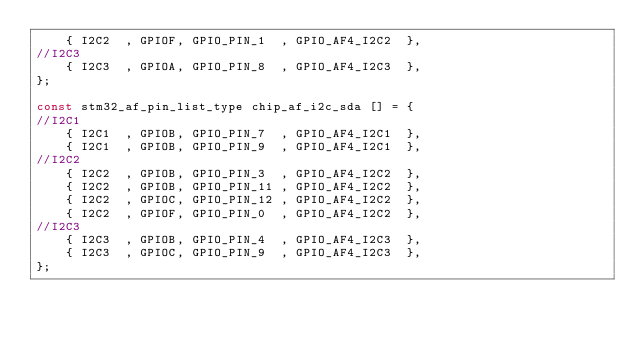<code> <loc_0><loc_0><loc_500><loc_500><_C_>    { I2C2  , GPIOF, GPIO_PIN_1  , GPIO_AF4_I2C2  }, 
//I2C3
    { I2C3  , GPIOA, GPIO_PIN_8  , GPIO_AF4_I2C3  }, 
}; 

const stm32_af_pin_list_type chip_af_i2c_sda [] = {
//I2C1
    { I2C1  , GPIOB, GPIO_PIN_7  , GPIO_AF4_I2C1  }, 
    { I2C1  , GPIOB, GPIO_PIN_9  , GPIO_AF4_I2C1  }, 
//I2C2
    { I2C2  , GPIOB, GPIO_PIN_3  , GPIO_AF4_I2C2  }, 
    { I2C2  , GPIOB, GPIO_PIN_11 , GPIO_AF4_I2C2  }, 
    { I2C2  , GPIOC, GPIO_PIN_12 , GPIO_AF4_I2C2  }, 
    { I2C2  , GPIOF, GPIO_PIN_0  , GPIO_AF4_I2C2  }, 
//I2C3
    { I2C3  , GPIOB, GPIO_PIN_4  , GPIO_AF4_I2C3  }, 
    { I2C3  , GPIOC, GPIO_PIN_9  , GPIO_AF4_I2C3  }, 
}; 
</code> 